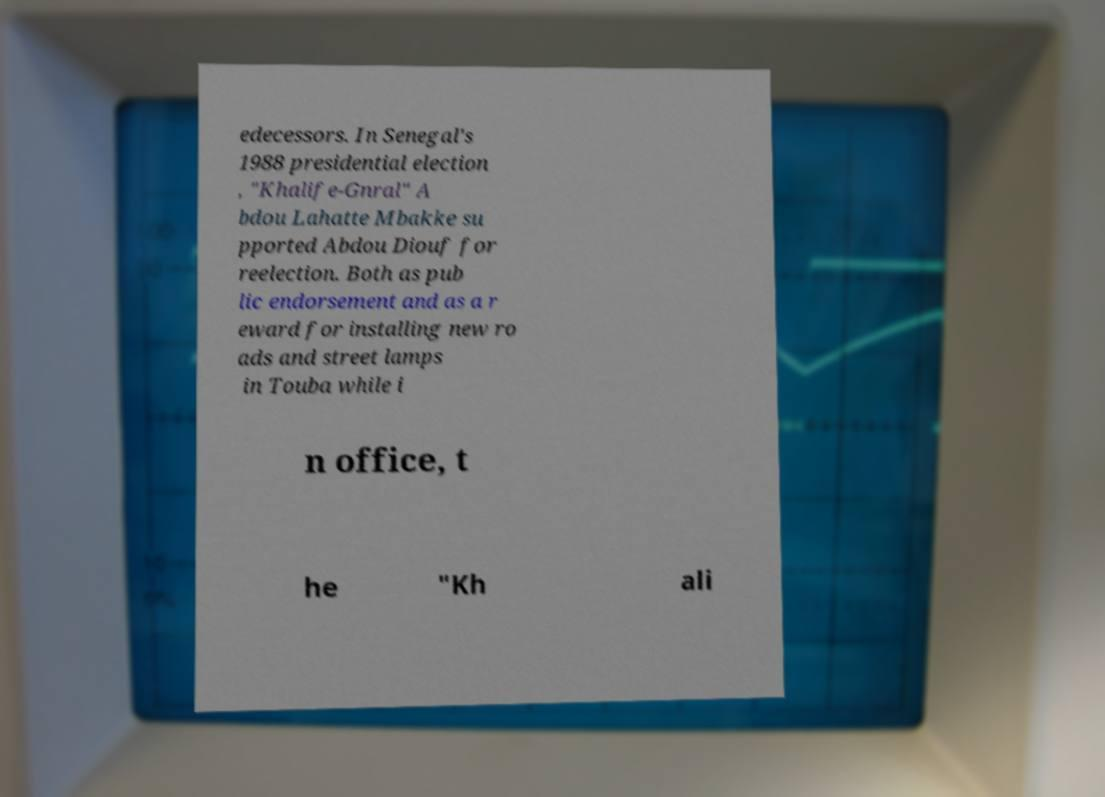Could you extract and type out the text from this image? edecessors. In Senegal's 1988 presidential election , "Khalife-Gnral" A bdou Lahatte Mbakke su pported Abdou Diouf for reelection. Both as pub lic endorsement and as a r eward for installing new ro ads and street lamps in Touba while i n office, t he "Kh ali 